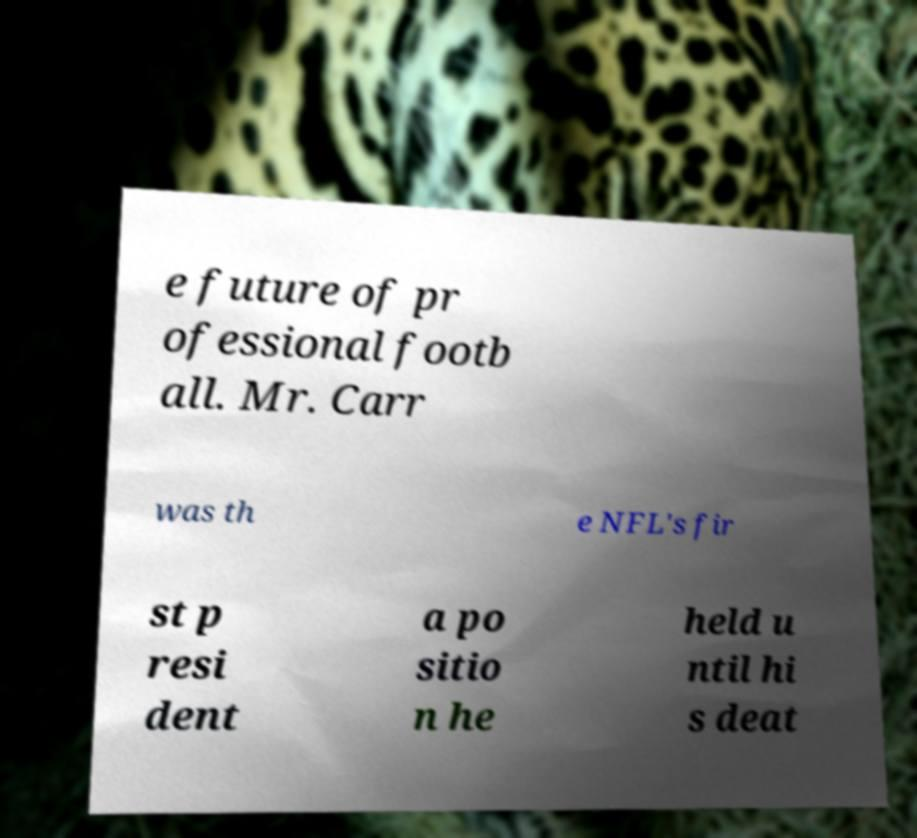Please read and relay the text visible in this image. What does it say? e future of pr ofessional footb all. Mr. Carr was th e NFL's fir st p resi dent a po sitio n he held u ntil hi s deat 